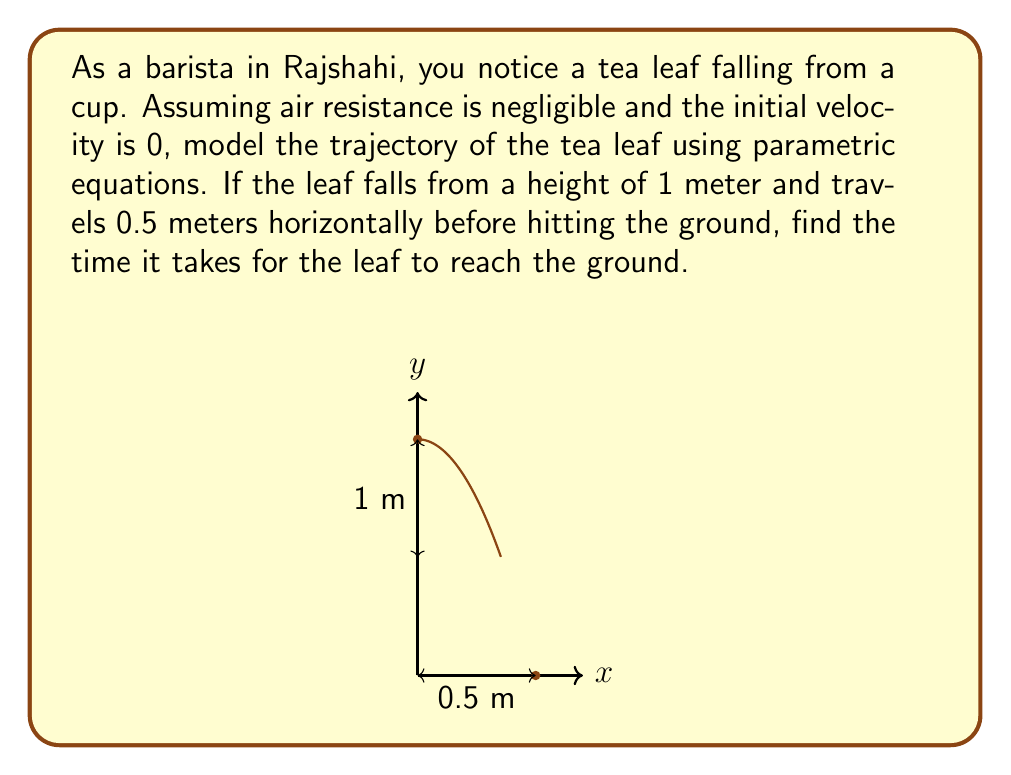Can you solve this math problem? Let's approach this step-by-step:

1) In parametric equations, we express x and y as functions of time t.

2) For horizontal motion with no initial velocity:
   $$x(t) = \frac{d}{T}t$$
   where d is the total horizontal distance and T is the total time.

3) For vertical motion under gravity:
   $$y(t) = h - \frac{1}{2}gt^2$$
   where h is the initial height and g is the acceleration due to gravity (9.8 m/s²).

4) We know the leaf hits the ground when y = 0. So:
   $$0 = h - \frac{1}{2}gt^2$$

5) Solving for t:
   $$\frac{1}{2}gt^2 = h$$
   $$t^2 = \frac{2h}{g}$$
   $$t = \sqrt{\frac{2h}{g}}$$

6) Plugging in the values (h = 1 m, g = 9.8 m/s²):
   $$t = \sqrt{\frac{2(1)}{9.8}} \approx 0.4518 \text{ seconds}$$

7) We can verify this by checking the horizontal distance:
   $$x(0.4518) = \frac{0.5}{0.4518}(0.4518) = 0.5 \text{ m}$$

Thus, the tea leaf takes approximately 0.4518 seconds to hit the ground.
Answer: $t \approx 0.4518 \text{ seconds}$ 